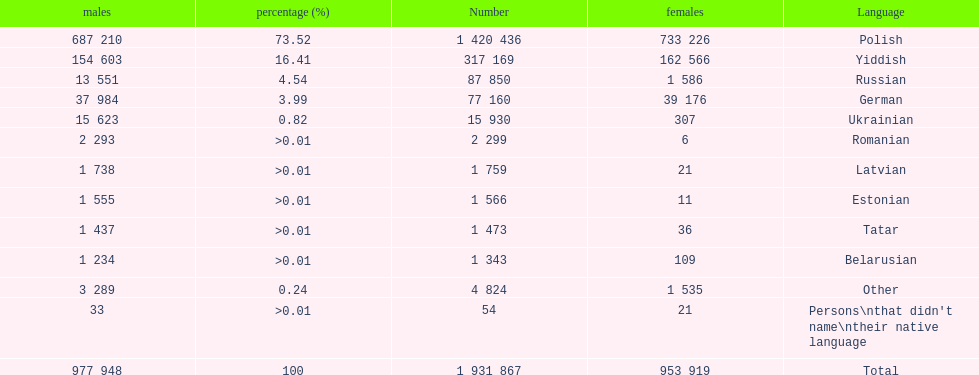Is german above or below russia in the number of people who speak that language? Below. 